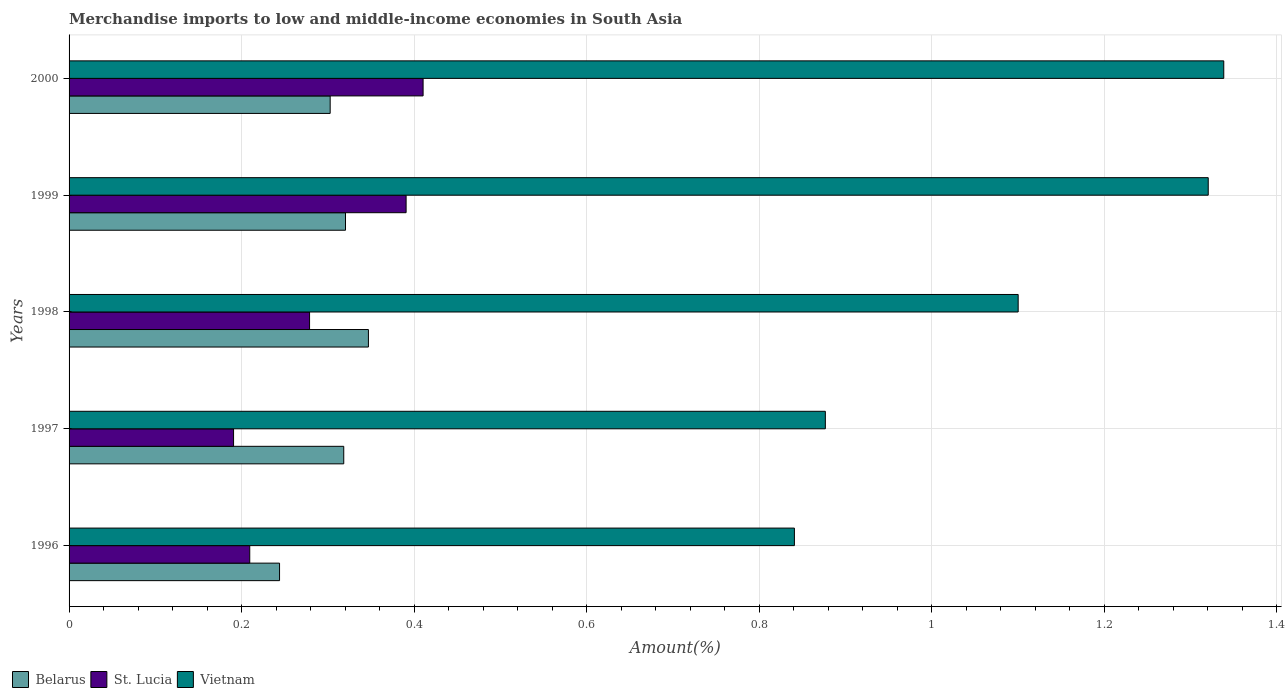How many different coloured bars are there?
Your answer should be very brief. 3. How many groups of bars are there?
Give a very brief answer. 5. Are the number of bars on each tick of the Y-axis equal?
Offer a very short reply. Yes. How many bars are there on the 5th tick from the bottom?
Your response must be concise. 3. What is the label of the 3rd group of bars from the top?
Provide a short and direct response. 1998. What is the percentage of amount earned from merchandise imports in Belarus in 1999?
Ensure brevity in your answer.  0.32. Across all years, what is the maximum percentage of amount earned from merchandise imports in Vietnam?
Ensure brevity in your answer.  1.34. Across all years, what is the minimum percentage of amount earned from merchandise imports in Vietnam?
Make the answer very short. 0.84. What is the total percentage of amount earned from merchandise imports in Vietnam in the graph?
Your answer should be compact. 5.48. What is the difference between the percentage of amount earned from merchandise imports in Belarus in 1999 and that in 2000?
Your answer should be compact. 0.02. What is the difference between the percentage of amount earned from merchandise imports in St. Lucia in 1996 and the percentage of amount earned from merchandise imports in Belarus in 2000?
Make the answer very short. -0.09. What is the average percentage of amount earned from merchandise imports in St. Lucia per year?
Your answer should be compact. 0.3. In the year 1997, what is the difference between the percentage of amount earned from merchandise imports in Vietnam and percentage of amount earned from merchandise imports in St. Lucia?
Offer a terse response. 0.69. What is the ratio of the percentage of amount earned from merchandise imports in Vietnam in 1999 to that in 2000?
Your response must be concise. 0.99. Is the difference between the percentage of amount earned from merchandise imports in Vietnam in 1996 and 1998 greater than the difference between the percentage of amount earned from merchandise imports in St. Lucia in 1996 and 1998?
Give a very brief answer. No. What is the difference between the highest and the second highest percentage of amount earned from merchandise imports in Belarus?
Give a very brief answer. 0.03. What is the difference between the highest and the lowest percentage of amount earned from merchandise imports in St. Lucia?
Your response must be concise. 0.22. Is the sum of the percentage of amount earned from merchandise imports in St. Lucia in 1998 and 1999 greater than the maximum percentage of amount earned from merchandise imports in Vietnam across all years?
Offer a very short reply. No. What does the 3rd bar from the top in 1998 represents?
Keep it short and to the point. Belarus. What does the 2nd bar from the bottom in 1998 represents?
Your response must be concise. St. Lucia. Is it the case that in every year, the sum of the percentage of amount earned from merchandise imports in St. Lucia and percentage of amount earned from merchandise imports in Vietnam is greater than the percentage of amount earned from merchandise imports in Belarus?
Your answer should be compact. Yes. What is the difference between two consecutive major ticks on the X-axis?
Offer a terse response. 0.2. Where does the legend appear in the graph?
Your answer should be compact. Bottom left. How are the legend labels stacked?
Offer a terse response. Horizontal. What is the title of the graph?
Offer a very short reply. Merchandise imports to low and middle-income economies in South Asia. What is the label or title of the X-axis?
Keep it short and to the point. Amount(%). What is the label or title of the Y-axis?
Offer a terse response. Years. What is the Amount(%) of Belarus in 1996?
Make the answer very short. 0.24. What is the Amount(%) of St. Lucia in 1996?
Give a very brief answer. 0.21. What is the Amount(%) in Vietnam in 1996?
Keep it short and to the point. 0.84. What is the Amount(%) of Belarus in 1997?
Your response must be concise. 0.32. What is the Amount(%) of St. Lucia in 1997?
Your answer should be very brief. 0.19. What is the Amount(%) in Vietnam in 1997?
Your answer should be compact. 0.88. What is the Amount(%) of Belarus in 1998?
Make the answer very short. 0.35. What is the Amount(%) in St. Lucia in 1998?
Provide a short and direct response. 0.28. What is the Amount(%) of Vietnam in 1998?
Offer a terse response. 1.1. What is the Amount(%) in Belarus in 1999?
Keep it short and to the point. 0.32. What is the Amount(%) of St. Lucia in 1999?
Your answer should be compact. 0.39. What is the Amount(%) of Vietnam in 1999?
Make the answer very short. 1.32. What is the Amount(%) of Belarus in 2000?
Ensure brevity in your answer.  0.3. What is the Amount(%) in St. Lucia in 2000?
Your answer should be compact. 0.41. What is the Amount(%) in Vietnam in 2000?
Ensure brevity in your answer.  1.34. Across all years, what is the maximum Amount(%) in Belarus?
Offer a terse response. 0.35. Across all years, what is the maximum Amount(%) of St. Lucia?
Your answer should be compact. 0.41. Across all years, what is the maximum Amount(%) in Vietnam?
Offer a very short reply. 1.34. Across all years, what is the minimum Amount(%) in Belarus?
Your answer should be very brief. 0.24. Across all years, what is the minimum Amount(%) in St. Lucia?
Keep it short and to the point. 0.19. Across all years, what is the minimum Amount(%) in Vietnam?
Provide a succinct answer. 0.84. What is the total Amount(%) in Belarus in the graph?
Make the answer very short. 1.53. What is the total Amount(%) of St. Lucia in the graph?
Give a very brief answer. 1.48. What is the total Amount(%) of Vietnam in the graph?
Offer a very short reply. 5.48. What is the difference between the Amount(%) of Belarus in 1996 and that in 1997?
Offer a terse response. -0.07. What is the difference between the Amount(%) of St. Lucia in 1996 and that in 1997?
Give a very brief answer. 0.02. What is the difference between the Amount(%) in Vietnam in 1996 and that in 1997?
Provide a short and direct response. -0.04. What is the difference between the Amount(%) in Belarus in 1996 and that in 1998?
Ensure brevity in your answer.  -0.1. What is the difference between the Amount(%) of St. Lucia in 1996 and that in 1998?
Give a very brief answer. -0.07. What is the difference between the Amount(%) in Vietnam in 1996 and that in 1998?
Offer a very short reply. -0.26. What is the difference between the Amount(%) of Belarus in 1996 and that in 1999?
Give a very brief answer. -0.08. What is the difference between the Amount(%) in St. Lucia in 1996 and that in 1999?
Offer a very short reply. -0.18. What is the difference between the Amount(%) of Vietnam in 1996 and that in 1999?
Ensure brevity in your answer.  -0.48. What is the difference between the Amount(%) in Belarus in 1996 and that in 2000?
Offer a terse response. -0.06. What is the difference between the Amount(%) in St. Lucia in 1996 and that in 2000?
Your response must be concise. -0.2. What is the difference between the Amount(%) in Vietnam in 1996 and that in 2000?
Your answer should be very brief. -0.5. What is the difference between the Amount(%) of Belarus in 1997 and that in 1998?
Provide a succinct answer. -0.03. What is the difference between the Amount(%) of St. Lucia in 1997 and that in 1998?
Provide a succinct answer. -0.09. What is the difference between the Amount(%) in Vietnam in 1997 and that in 1998?
Give a very brief answer. -0.22. What is the difference between the Amount(%) in Belarus in 1997 and that in 1999?
Give a very brief answer. -0. What is the difference between the Amount(%) of St. Lucia in 1997 and that in 1999?
Keep it short and to the point. -0.2. What is the difference between the Amount(%) of Vietnam in 1997 and that in 1999?
Make the answer very short. -0.44. What is the difference between the Amount(%) in Belarus in 1997 and that in 2000?
Make the answer very short. 0.02. What is the difference between the Amount(%) of St. Lucia in 1997 and that in 2000?
Give a very brief answer. -0.22. What is the difference between the Amount(%) of Vietnam in 1997 and that in 2000?
Make the answer very short. -0.46. What is the difference between the Amount(%) of Belarus in 1998 and that in 1999?
Provide a succinct answer. 0.03. What is the difference between the Amount(%) in St. Lucia in 1998 and that in 1999?
Give a very brief answer. -0.11. What is the difference between the Amount(%) in Vietnam in 1998 and that in 1999?
Ensure brevity in your answer.  -0.22. What is the difference between the Amount(%) of Belarus in 1998 and that in 2000?
Your response must be concise. 0.04. What is the difference between the Amount(%) in St. Lucia in 1998 and that in 2000?
Offer a very short reply. -0.13. What is the difference between the Amount(%) of Vietnam in 1998 and that in 2000?
Give a very brief answer. -0.24. What is the difference between the Amount(%) in Belarus in 1999 and that in 2000?
Your response must be concise. 0.02. What is the difference between the Amount(%) in St. Lucia in 1999 and that in 2000?
Provide a short and direct response. -0.02. What is the difference between the Amount(%) of Vietnam in 1999 and that in 2000?
Offer a very short reply. -0.02. What is the difference between the Amount(%) of Belarus in 1996 and the Amount(%) of St. Lucia in 1997?
Offer a terse response. 0.05. What is the difference between the Amount(%) of Belarus in 1996 and the Amount(%) of Vietnam in 1997?
Your response must be concise. -0.63. What is the difference between the Amount(%) in St. Lucia in 1996 and the Amount(%) in Vietnam in 1997?
Ensure brevity in your answer.  -0.67. What is the difference between the Amount(%) in Belarus in 1996 and the Amount(%) in St. Lucia in 1998?
Give a very brief answer. -0.03. What is the difference between the Amount(%) of Belarus in 1996 and the Amount(%) of Vietnam in 1998?
Ensure brevity in your answer.  -0.86. What is the difference between the Amount(%) of St. Lucia in 1996 and the Amount(%) of Vietnam in 1998?
Your response must be concise. -0.89. What is the difference between the Amount(%) of Belarus in 1996 and the Amount(%) of St. Lucia in 1999?
Your answer should be very brief. -0.15. What is the difference between the Amount(%) in Belarus in 1996 and the Amount(%) in Vietnam in 1999?
Offer a terse response. -1.08. What is the difference between the Amount(%) in St. Lucia in 1996 and the Amount(%) in Vietnam in 1999?
Give a very brief answer. -1.11. What is the difference between the Amount(%) of Belarus in 1996 and the Amount(%) of St. Lucia in 2000?
Your response must be concise. -0.17. What is the difference between the Amount(%) of Belarus in 1996 and the Amount(%) of Vietnam in 2000?
Your answer should be very brief. -1.09. What is the difference between the Amount(%) in St. Lucia in 1996 and the Amount(%) in Vietnam in 2000?
Your answer should be compact. -1.13. What is the difference between the Amount(%) of Belarus in 1997 and the Amount(%) of St. Lucia in 1998?
Make the answer very short. 0.04. What is the difference between the Amount(%) in Belarus in 1997 and the Amount(%) in Vietnam in 1998?
Your answer should be very brief. -0.78. What is the difference between the Amount(%) in St. Lucia in 1997 and the Amount(%) in Vietnam in 1998?
Make the answer very short. -0.91. What is the difference between the Amount(%) of Belarus in 1997 and the Amount(%) of St. Lucia in 1999?
Your answer should be very brief. -0.07. What is the difference between the Amount(%) in Belarus in 1997 and the Amount(%) in Vietnam in 1999?
Offer a terse response. -1. What is the difference between the Amount(%) in St. Lucia in 1997 and the Amount(%) in Vietnam in 1999?
Your answer should be very brief. -1.13. What is the difference between the Amount(%) in Belarus in 1997 and the Amount(%) in St. Lucia in 2000?
Provide a short and direct response. -0.09. What is the difference between the Amount(%) in Belarus in 1997 and the Amount(%) in Vietnam in 2000?
Your answer should be very brief. -1.02. What is the difference between the Amount(%) of St. Lucia in 1997 and the Amount(%) of Vietnam in 2000?
Make the answer very short. -1.15. What is the difference between the Amount(%) in Belarus in 1998 and the Amount(%) in St. Lucia in 1999?
Offer a very short reply. -0.04. What is the difference between the Amount(%) in Belarus in 1998 and the Amount(%) in Vietnam in 1999?
Your answer should be compact. -0.97. What is the difference between the Amount(%) of St. Lucia in 1998 and the Amount(%) of Vietnam in 1999?
Give a very brief answer. -1.04. What is the difference between the Amount(%) in Belarus in 1998 and the Amount(%) in St. Lucia in 2000?
Make the answer very short. -0.06. What is the difference between the Amount(%) of Belarus in 1998 and the Amount(%) of Vietnam in 2000?
Provide a succinct answer. -0.99. What is the difference between the Amount(%) of St. Lucia in 1998 and the Amount(%) of Vietnam in 2000?
Give a very brief answer. -1.06. What is the difference between the Amount(%) of Belarus in 1999 and the Amount(%) of St. Lucia in 2000?
Give a very brief answer. -0.09. What is the difference between the Amount(%) of Belarus in 1999 and the Amount(%) of Vietnam in 2000?
Offer a terse response. -1.02. What is the difference between the Amount(%) in St. Lucia in 1999 and the Amount(%) in Vietnam in 2000?
Your answer should be compact. -0.95. What is the average Amount(%) in Belarus per year?
Your answer should be very brief. 0.31. What is the average Amount(%) in St. Lucia per year?
Make the answer very short. 0.3. What is the average Amount(%) of Vietnam per year?
Give a very brief answer. 1.1. In the year 1996, what is the difference between the Amount(%) of Belarus and Amount(%) of St. Lucia?
Provide a succinct answer. 0.03. In the year 1996, what is the difference between the Amount(%) in Belarus and Amount(%) in Vietnam?
Keep it short and to the point. -0.6. In the year 1996, what is the difference between the Amount(%) of St. Lucia and Amount(%) of Vietnam?
Provide a short and direct response. -0.63. In the year 1997, what is the difference between the Amount(%) of Belarus and Amount(%) of St. Lucia?
Keep it short and to the point. 0.13. In the year 1997, what is the difference between the Amount(%) in Belarus and Amount(%) in Vietnam?
Keep it short and to the point. -0.56. In the year 1997, what is the difference between the Amount(%) in St. Lucia and Amount(%) in Vietnam?
Ensure brevity in your answer.  -0.69. In the year 1998, what is the difference between the Amount(%) of Belarus and Amount(%) of St. Lucia?
Your answer should be compact. 0.07. In the year 1998, what is the difference between the Amount(%) in Belarus and Amount(%) in Vietnam?
Your answer should be very brief. -0.75. In the year 1998, what is the difference between the Amount(%) in St. Lucia and Amount(%) in Vietnam?
Ensure brevity in your answer.  -0.82. In the year 1999, what is the difference between the Amount(%) in Belarus and Amount(%) in St. Lucia?
Your answer should be very brief. -0.07. In the year 1999, what is the difference between the Amount(%) of Belarus and Amount(%) of Vietnam?
Ensure brevity in your answer.  -1. In the year 1999, what is the difference between the Amount(%) in St. Lucia and Amount(%) in Vietnam?
Offer a terse response. -0.93. In the year 2000, what is the difference between the Amount(%) in Belarus and Amount(%) in St. Lucia?
Give a very brief answer. -0.11. In the year 2000, what is the difference between the Amount(%) of Belarus and Amount(%) of Vietnam?
Make the answer very short. -1.04. In the year 2000, what is the difference between the Amount(%) in St. Lucia and Amount(%) in Vietnam?
Offer a terse response. -0.93. What is the ratio of the Amount(%) in Belarus in 1996 to that in 1997?
Offer a very short reply. 0.77. What is the ratio of the Amount(%) in St. Lucia in 1996 to that in 1997?
Offer a very short reply. 1.1. What is the ratio of the Amount(%) of Vietnam in 1996 to that in 1997?
Your response must be concise. 0.96. What is the ratio of the Amount(%) in Belarus in 1996 to that in 1998?
Offer a very short reply. 0.7. What is the ratio of the Amount(%) of St. Lucia in 1996 to that in 1998?
Offer a terse response. 0.75. What is the ratio of the Amount(%) of Vietnam in 1996 to that in 1998?
Your response must be concise. 0.76. What is the ratio of the Amount(%) in Belarus in 1996 to that in 1999?
Your answer should be very brief. 0.76. What is the ratio of the Amount(%) of St. Lucia in 1996 to that in 1999?
Provide a short and direct response. 0.54. What is the ratio of the Amount(%) in Vietnam in 1996 to that in 1999?
Your response must be concise. 0.64. What is the ratio of the Amount(%) of Belarus in 1996 to that in 2000?
Offer a terse response. 0.81. What is the ratio of the Amount(%) of St. Lucia in 1996 to that in 2000?
Keep it short and to the point. 0.51. What is the ratio of the Amount(%) in Vietnam in 1996 to that in 2000?
Keep it short and to the point. 0.63. What is the ratio of the Amount(%) of Belarus in 1997 to that in 1998?
Provide a short and direct response. 0.92. What is the ratio of the Amount(%) of St. Lucia in 1997 to that in 1998?
Provide a succinct answer. 0.68. What is the ratio of the Amount(%) of Vietnam in 1997 to that in 1998?
Ensure brevity in your answer.  0.8. What is the ratio of the Amount(%) of Belarus in 1997 to that in 1999?
Your response must be concise. 0.99. What is the ratio of the Amount(%) of St. Lucia in 1997 to that in 1999?
Your answer should be very brief. 0.49. What is the ratio of the Amount(%) of Vietnam in 1997 to that in 1999?
Offer a very short reply. 0.66. What is the ratio of the Amount(%) in Belarus in 1997 to that in 2000?
Your answer should be compact. 1.05. What is the ratio of the Amount(%) of St. Lucia in 1997 to that in 2000?
Give a very brief answer. 0.46. What is the ratio of the Amount(%) in Vietnam in 1997 to that in 2000?
Your answer should be compact. 0.66. What is the ratio of the Amount(%) of Belarus in 1998 to that in 1999?
Make the answer very short. 1.08. What is the ratio of the Amount(%) in St. Lucia in 1998 to that in 1999?
Offer a very short reply. 0.71. What is the ratio of the Amount(%) of Vietnam in 1998 to that in 1999?
Your response must be concise. 0.83. What is the ratio of the Amount(%) in Belarus in 1998 to that in 2000?
Your answer should be compact. 1.15. What is the ratio of the Amount(%) of St. Lucia in 1998 to that in 2000?
Offer a very short reply. 0.68. What is the ratio of the Amount(%) of Vietnam in 1998 to that in 2000?
Your answer should be compact. 0.82. What is the ratio of the Amount(%) in Belarus in 1999 to that in 2000?
Make the answer very short. 1.06. What is the ratio of the Amount(%) of St. Lucia in 1999 to that in 2000?
Offer a terse response. 0.95. What is the ratio of the Amount(%) of Vietnam in 1999 to that in 2000?
Provide a short and direct response. 0.99. What is the difference between the highest and the second highest Amount(%) in Belarus?
Keep it short and to the point. 0.03. What is the difference between the highest and the second highest Amount(%) in St. Lucia?
Offer a very short reply. 0.02. What is the difference between the highest and the second highest Amount(%) in Vietnam?
Your response must be concise. 0.02. What is the difference between the highest and the lowest Amount(%) of Belarus?
Your answer should be compact. 0.1. What is the difference between the highest and the lowest Amount(%) of St. Lucia?
Ensure brevity in your answer.  0.22. What is the difference between the highest and the lowest Amount(%) in Vietnam?
Keep it short and to the point. 0.5. 